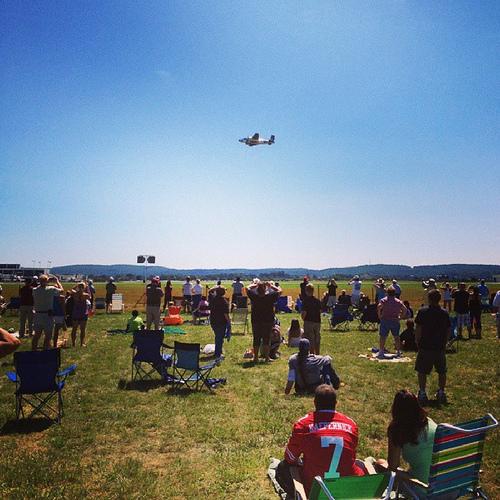How many aircrafts do you see in the image and can you describe them? There is only one aircraft visible in the image. It is flying overhead, and seems to be a small, single-engine plane. Create a detailed backstory for the pilot of the aircraft. Captain Alex Thompson has always had a passion for flying. Growing up near a small airfield, he spent countless hours watching planes take off and land, dreaming of one day joining their ranks. Alex joined the Air Force right after high school and excelled in his flight training. After serving with distinction, he became a commercial pilot. However, his first love was always stunt flying. On weekends, he volunteers to perform at air shows, showcasing his skills and inspiring the next generation of pilots. Today, he’s performing at the local air show, thrilling the crowd with his precision maneuvers and daring stunts. His journey to the skies is a testament to hard work, dedication, and an unyielding passion for flight. Based on the image, what activities might follow during the event after the plane's performance? After the plane's performance, there might be more aerial displays featuring different types of aircrafts, possibly including vintage planes, jets, and aerobatic teams. There could also be ground activities like meet-and-greet sessions with pilots, aircraft static displays, food stalls, and souvenir shops. People might also enjoy family-friendly activities like face painting, games, and live music. 